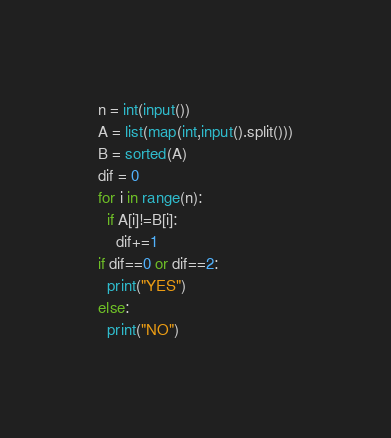<code> <loc_0><loc_0><loc_500><loc_500><_Python_>n = int(input())
A = list(map(int,input().split()))
B = sorted(A)
dif = 0
for i in range(n):
  if A[i]!=B[i]:
    dif+=1
if dif==0 or dif==2:
  print("YES")
else:
  print("NO")</code> 